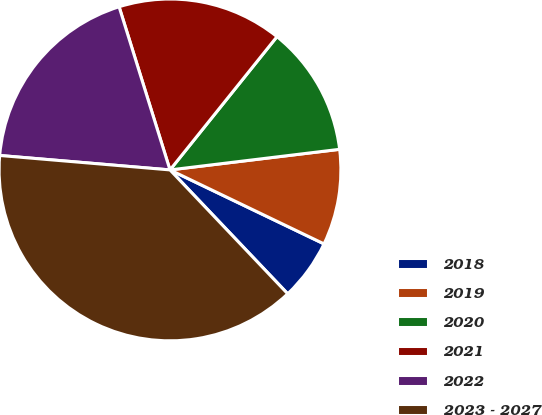Convert chart. <chart><loc_0><loc_0><loc_500><loc_500><pie_chart><fcel>2018<fcel>2019<fcel>2020<fcel>2021<fcel>2022<fcel>2023 - 2027<nl><fcel>5.78%<fcel>9.05%<fcel>12.31%<fcel>15.58%<fcel>18.84%<fcel>38.44%<nl></chart> 